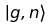Convert formula to latex. <formula><loc_0><loc_0><loc_500><loc_500>| g , n \rangle</formula> 